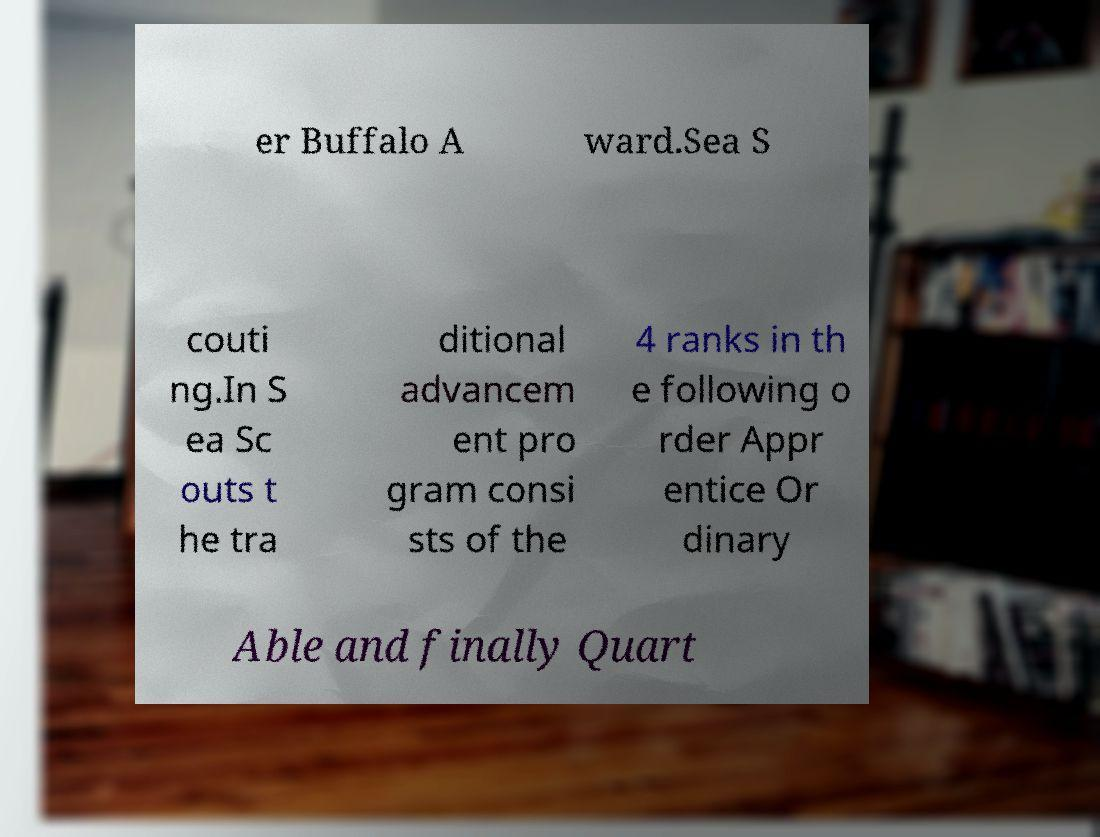Can you read and provide the text displayed in the image?This photo seems to have some interesting text. Can you extract and type it out for me? er Buffalo A ward.Sea S couti ng.In S ea Sc outs t he tra ditional advancem ent pro gram consi sts of the 4 ranks in th e following o rder Appr entice Or dinary Able and finally Quart 